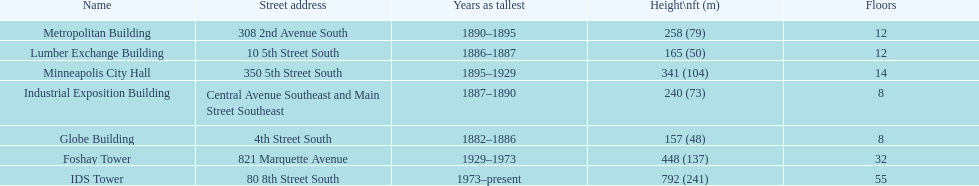Is the metropolitan building or the lumber exchange building taller? Metropolitan Building. 